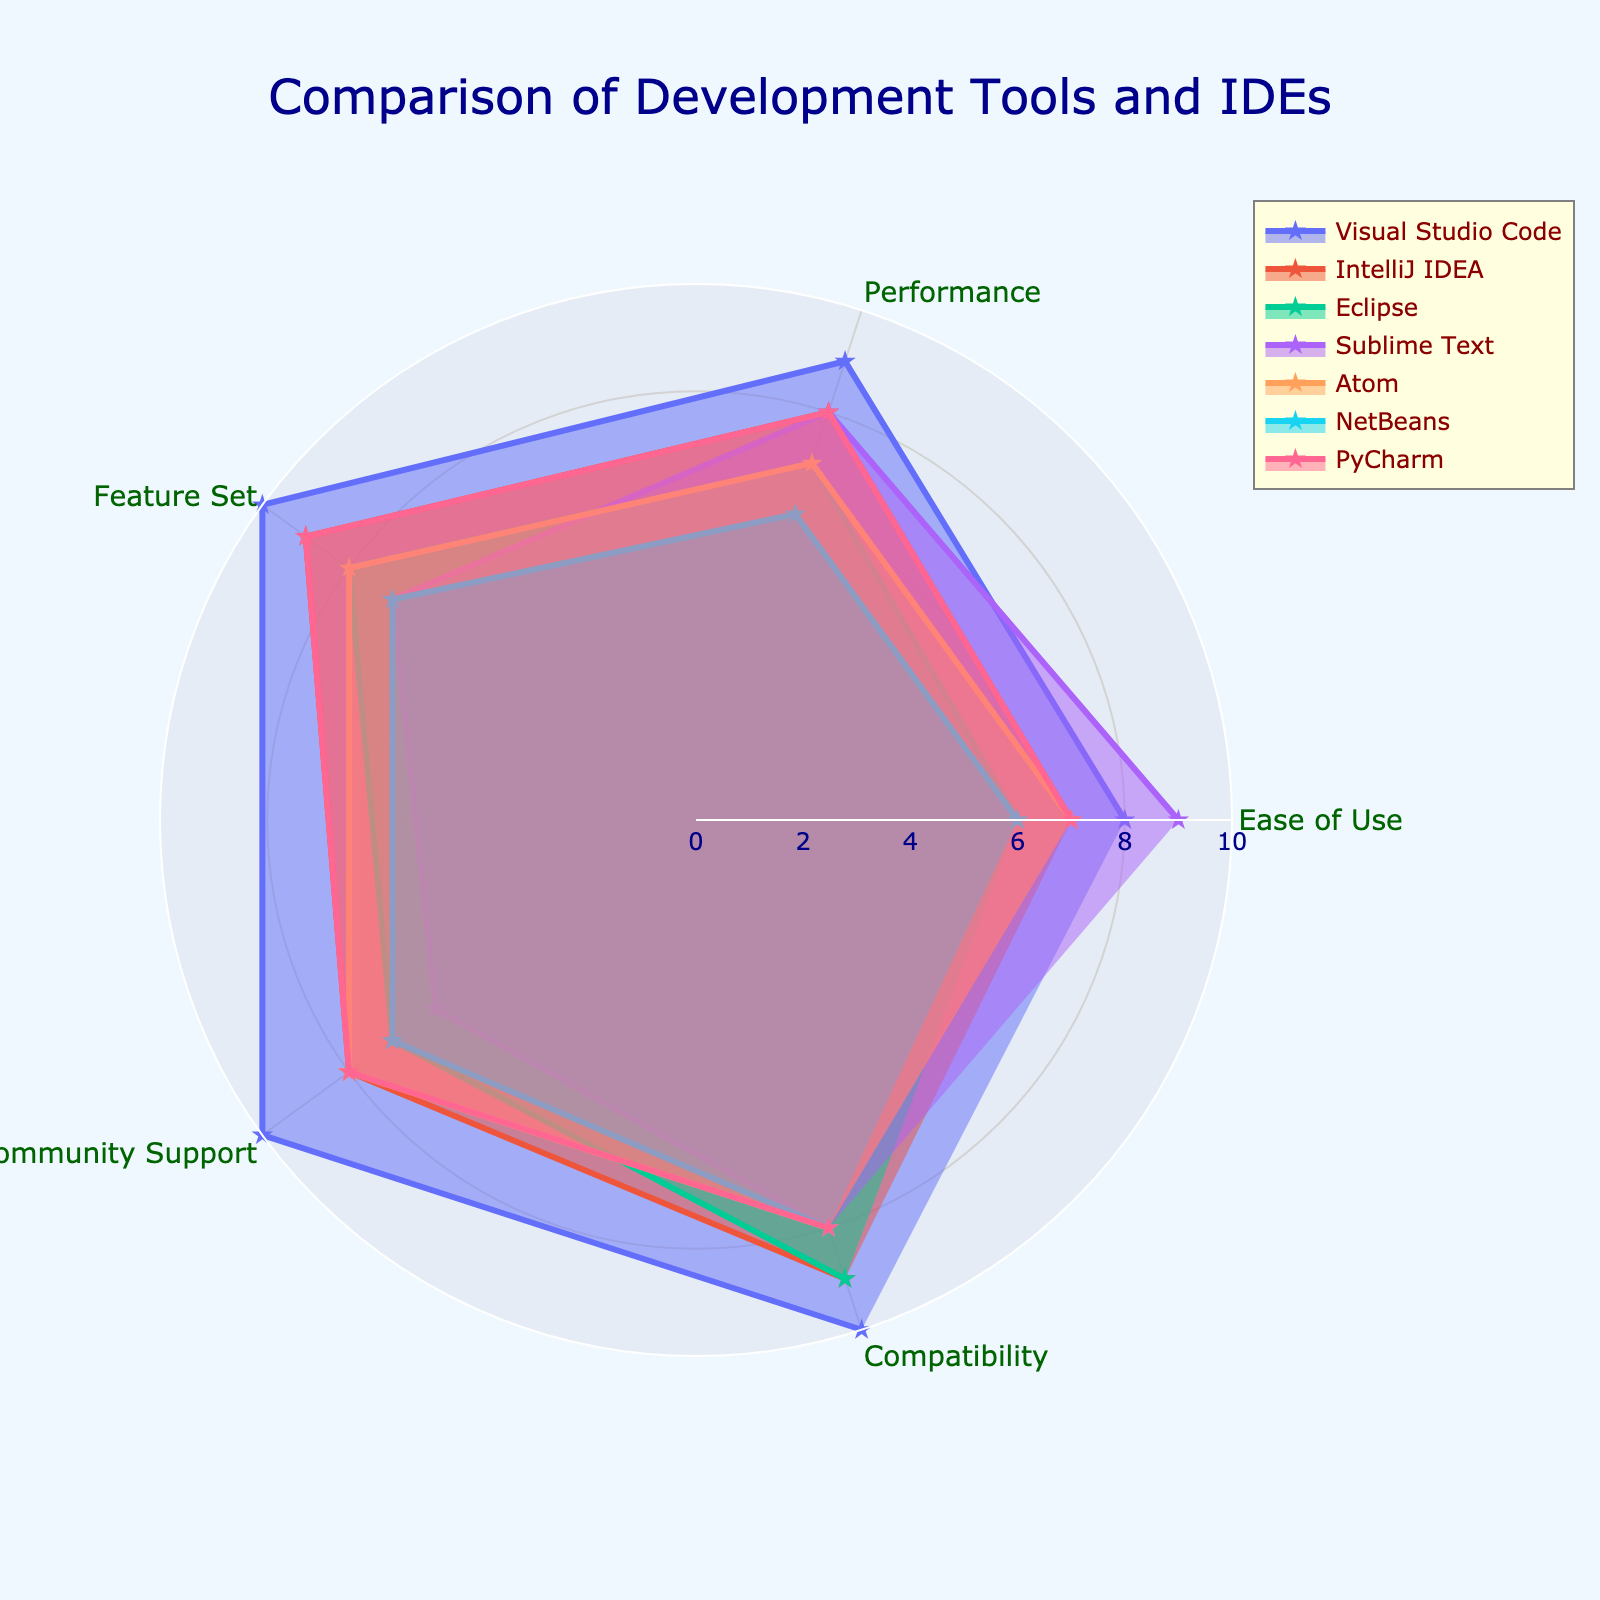What's the title of the radar chart? The title of the radar chart is positioned at the top center of the figure. It is prominently displayed in a larger, dark blue font.
Answer: Comparison of Development Tools and IDEs Which tool scores highest in Feature Set? By examining the "Feature Set" axis, we can see that Visual Studio Code has the maximum score of 10.
Answer: Visual Studio Code What is the average score of Eclipse across all categories? Calculate the average by summing Eclipse's scores (6 + 7 + 8 + 7 + 9) which equals 37, then divide by the number of categories (5). 37 divided by 5 is 7.4.
Answer: 7.4 Which tool has the lowest score in Community Support? By looking at the "Community Support" axis, the lowest score is a 6, which belongs to Sublime Text.
Answer: Sublime Text Compare Performance between IntelliJ IDEA and PyCharm. Which one is higher? Looking at the "Performance" axis, IntelliJ IDEA has a score of 8, while PyCharm also has a score of 8. Therefore, both are equal.
Answer: Both are equal Which tool has the most balanced scores across all categories? A balanced tool would have similar scores across all categories with no prominent peaks or valleys. Visual comparison shows that Atom has scores that are very similar across all areas (7, 7, 8, 8, 8).
Answer: Atom How does NetBeans perform in terms of Compatibility compared to other tools? By inspecting the "Compatibility" axis, NetBeans has a score of 8. Sublime Text, Atom, IntelliJ IDEA, and Eclipse also score 8 here, but Visual Studio Code scores higher with a 10. So, NetBeans is on par with most, but lower than Visual Studio Code.
Answer: On par with most, lower than Visual Studio Code What is the most outstanding feature of Visual Studio Code according to the radar chart? The radar chart shows that Visual Studio Code's highest scores are in Feature Set, Community Support, and Compatibility, all scoring 10. Hence, any of these could be considered the most outstanding.
Answer: Feature Set, Community Support, Compatibility Compare the overall performance (sum of all categories) of IntelliJ IDEA and Atom, and determine which one fares better. Summarize the scores for IntelliJ IDEA (7 + 8 + 9 + 8 + 9 = 41) and Atom (7 + 7 + 8 + 8 + 8 = 38). IntelliJ IDEA has a higher sum of 41 compared to Atom's 38.
Answer: IntelliJ IDEA Considering Performance and Community Support, which tool stands out? Looking at both "Performance" and "Community Support" axes, Visual Studio Code stands out as it scores 9 and 10, respectively.
Answer: Visual Studio Code 